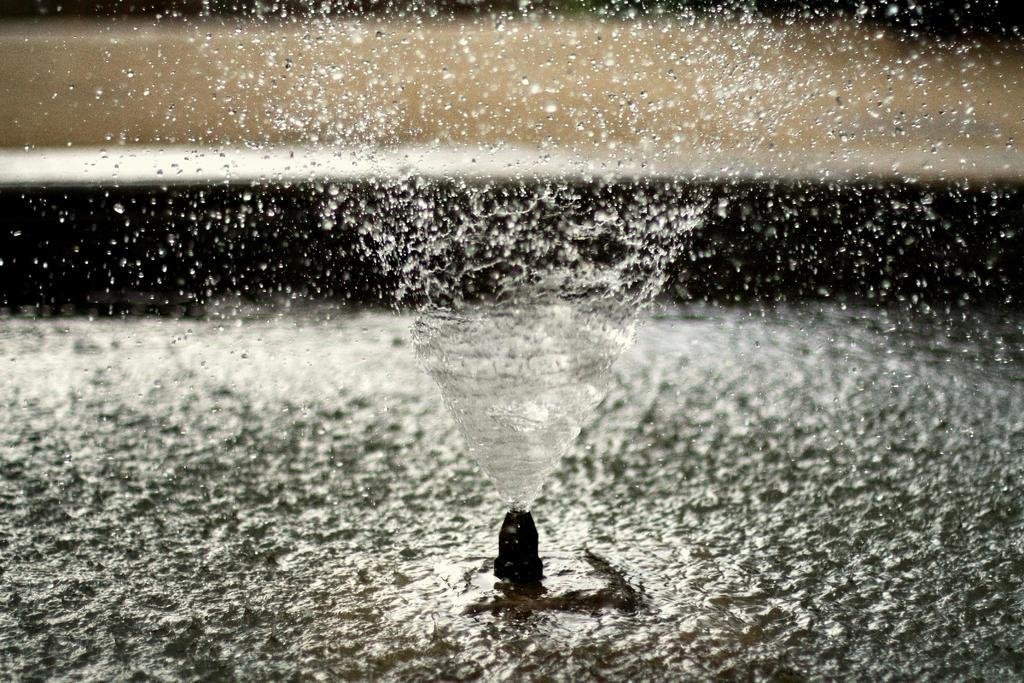What is present in the image that involves water? There is water visible in the image, and it is coming from a sprinkler. Can you describe the source of the water in the image? The water is coming from a sprinkler in the image. How does the sprinkler affect the wealth of the people in the image? There is no information about people or wealth in the image, as it only features water coming from a sprinkler. 